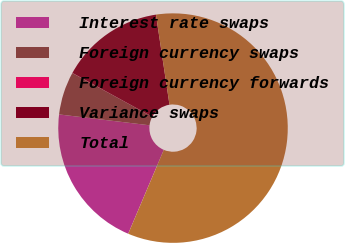<chart> <loc_0><loc_0><loc_500><loc_500><pie_chart><fcel>Interest rate swaps<fcel>Foreign currency swaps<fcel>Foreign currency forwards<fcel>Variance swaps<fcel>Total<nl><fcel>20.52%<fcel>6.06%<fcel>0.02%<fcel>14.64%<fcel>58.76%<nl></chart> 